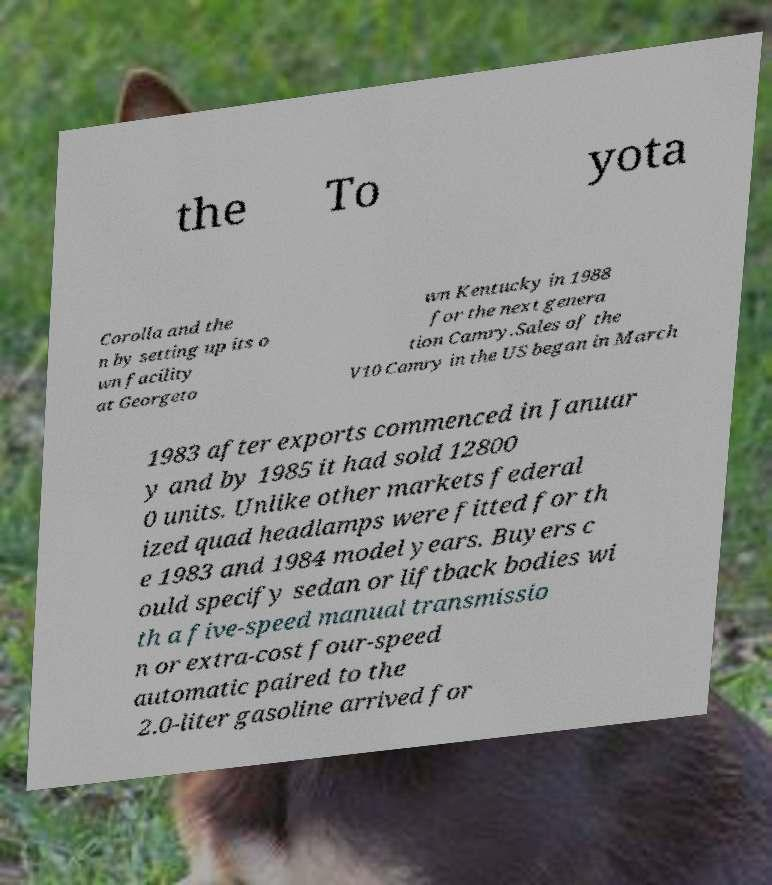What messages or text are displayed in this image? I need them in a readable, typed format. the To yota Corolla and the n by setting up its o wn facility at Georgeto wn Kentucky in 1988 for the next genera tion Camry.Sales of the V10 Camry in the US began in March 1983 after exports commenced in Januar y and by 1985 it had sold 12800 0 units. Unlike other markets federal ized quad headlamps were fitted for th e 1983 and 1984 model years. Buyers c ould specify sedan or liftback bodies wi th a five-speed manual transmissio n or extra-cost four-speed automatic paired to the 2.0-liter gasoline arrived for 